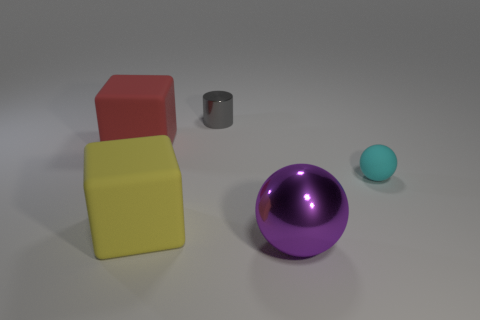Is the number of tiny gray shiny objects that are to the right of the tiny cylinder less than the number of metallic balls that are behind the yellow rubber object? Actually, assessing the image, we find that there is only one tiny gray shiny cylinder to the right of the larger central purple metallic ball. Behind the yellow cube, however, there is just one metallic ball, a larger purple one. Therefore, the numbers are equal, with one object in each described location, not less. 